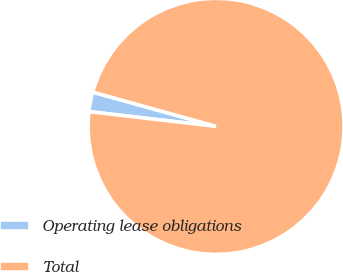Convert chart. <chart><loc_0><loc_0><loc_500><loc_500><pie_chart><fcel>Operating lease obligations<fcel>Total<nl><fcel>2.47%<fcel>97.53%<nl></chart> 